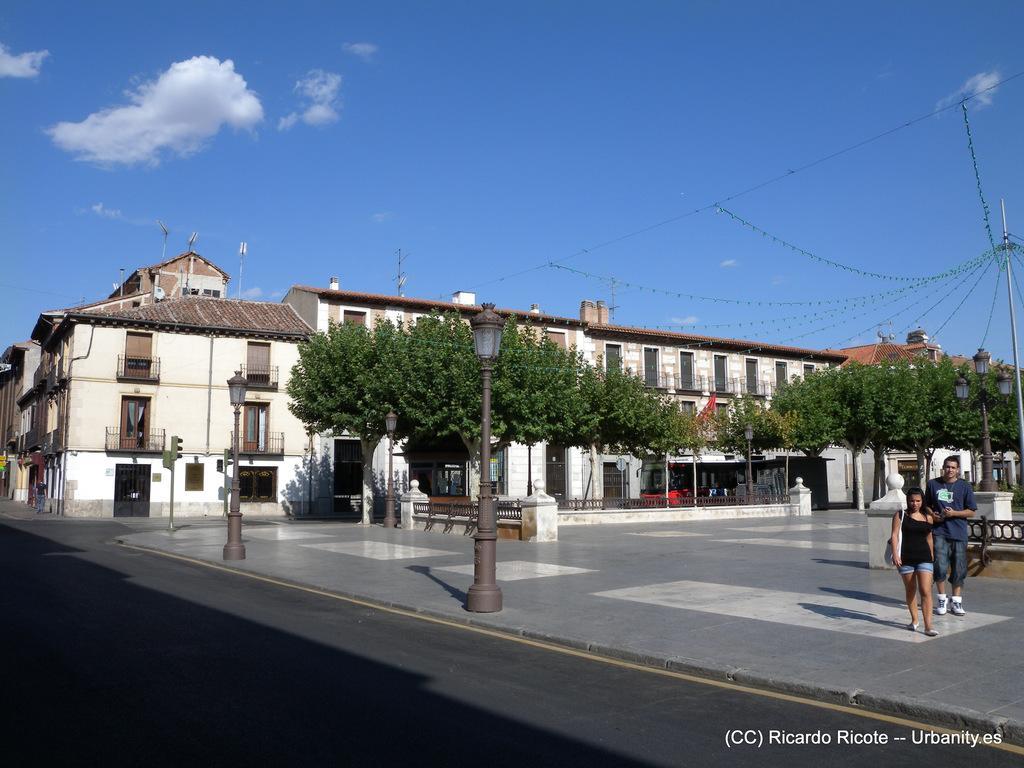Please provide a concise description of this image. In the foreground of this image, there is a road. In the middle, there is a pavement on which, there are two people walking on it on the right. We can also see trees, railing, poles, buildings and cables. At the top, there is the sky. 